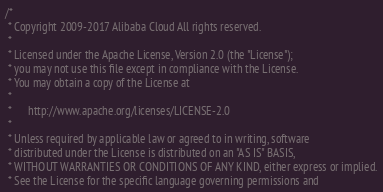<code> <loc_0><loc_0><loc_500><loc_500><_C++_>/*
 * Copyright 2009-2017 Alibaba Cloud All rights reserved.
 * 
 * Licensed under the Apache License, Version 2.0 (the "License");
 * you may not use this file except in compliance with the License.
 * You may obtain a copy of the License at
 * 
 *      http://www.apache.org/licenses/LICENSE-2.0
 * 
 * Unless required by applicable law or agreed to in writing, software
 * distributed under the License is distributed on an "AS IS" BASIS,
 * WITHOUT WARRANTIES OR CONDITIONS OF ANY KIND, either express or implied.
 * See the License for the specific language governing permissions and</code> 